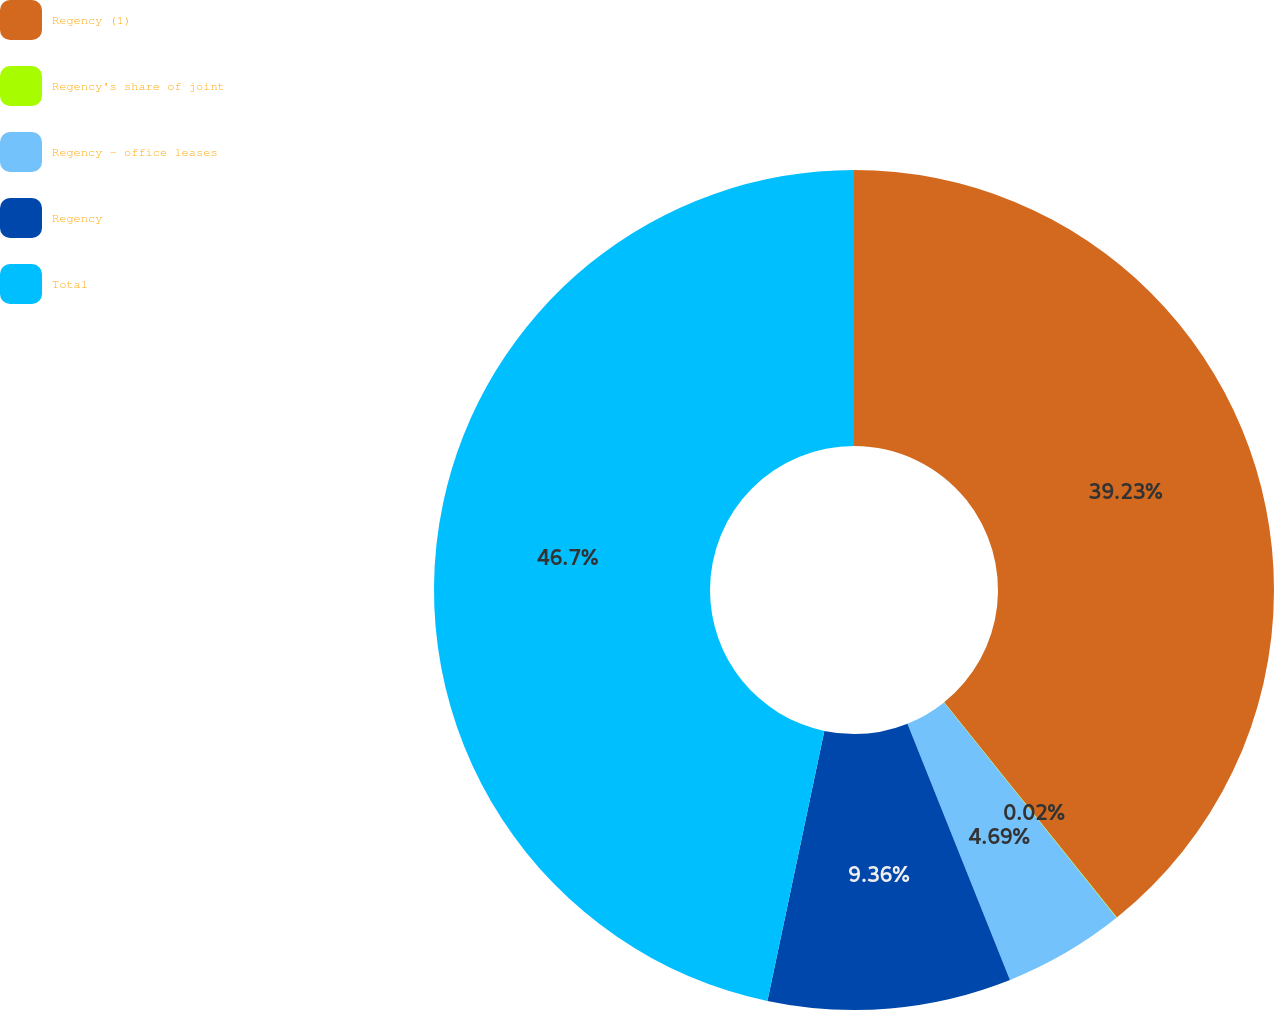Convert chart. <chart><loc_0><loc_0><loc_500><loc_500><pie_chart><fcel>Regency (1)<fcel>Regency's share of joint<fcel>Regency - office leases<fcel>Regency<fcel>Total<nl><fcel>39.23%<fcel>0.02%<fcel>4.69%<fcel>9.36%<fcel>46.69%<nl></chart> 